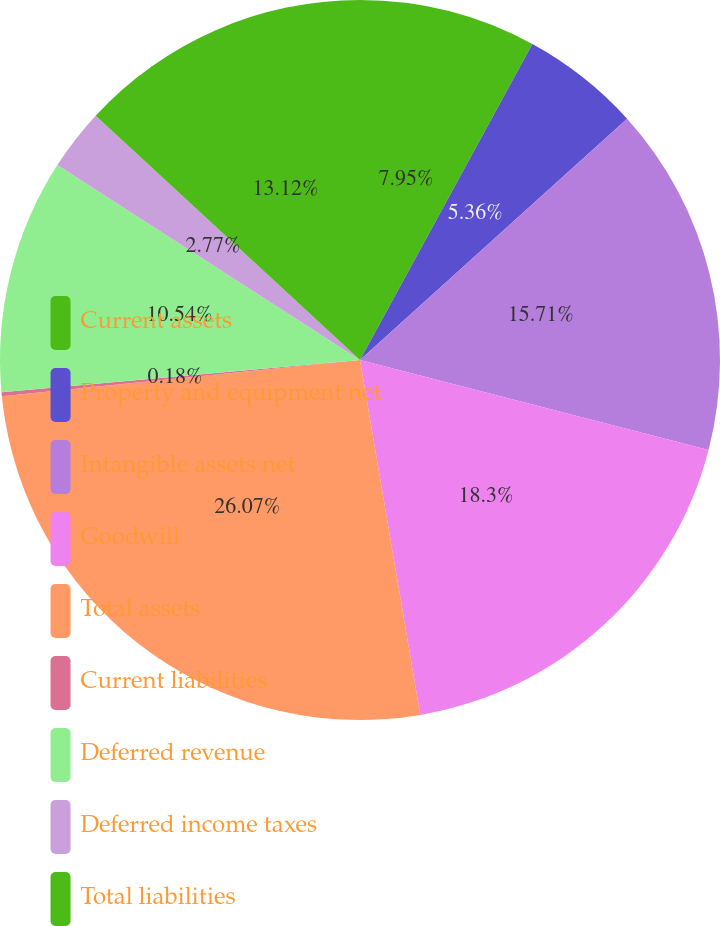<chart> <loc_0><loc_0><loc_500><loc_500><pie_chart><fcel>Current assets<fcel>Property and equipment net<fcel>Intangible assets net<fcel>Goodwill<fcel>Total assets<fcel>Current liabilities<fcel>Deferred revenue<fcel>Deferred income taxes<fcel>Total liabilities<nl><fcel>7.95%<fcel>5.36%<fcel>15.72%<fcel>18.31%<fcel>26.08%<fcel>0.18%<fcel>10.54%<fcel>2.77%<fcel>13.13%<nl></chart> 